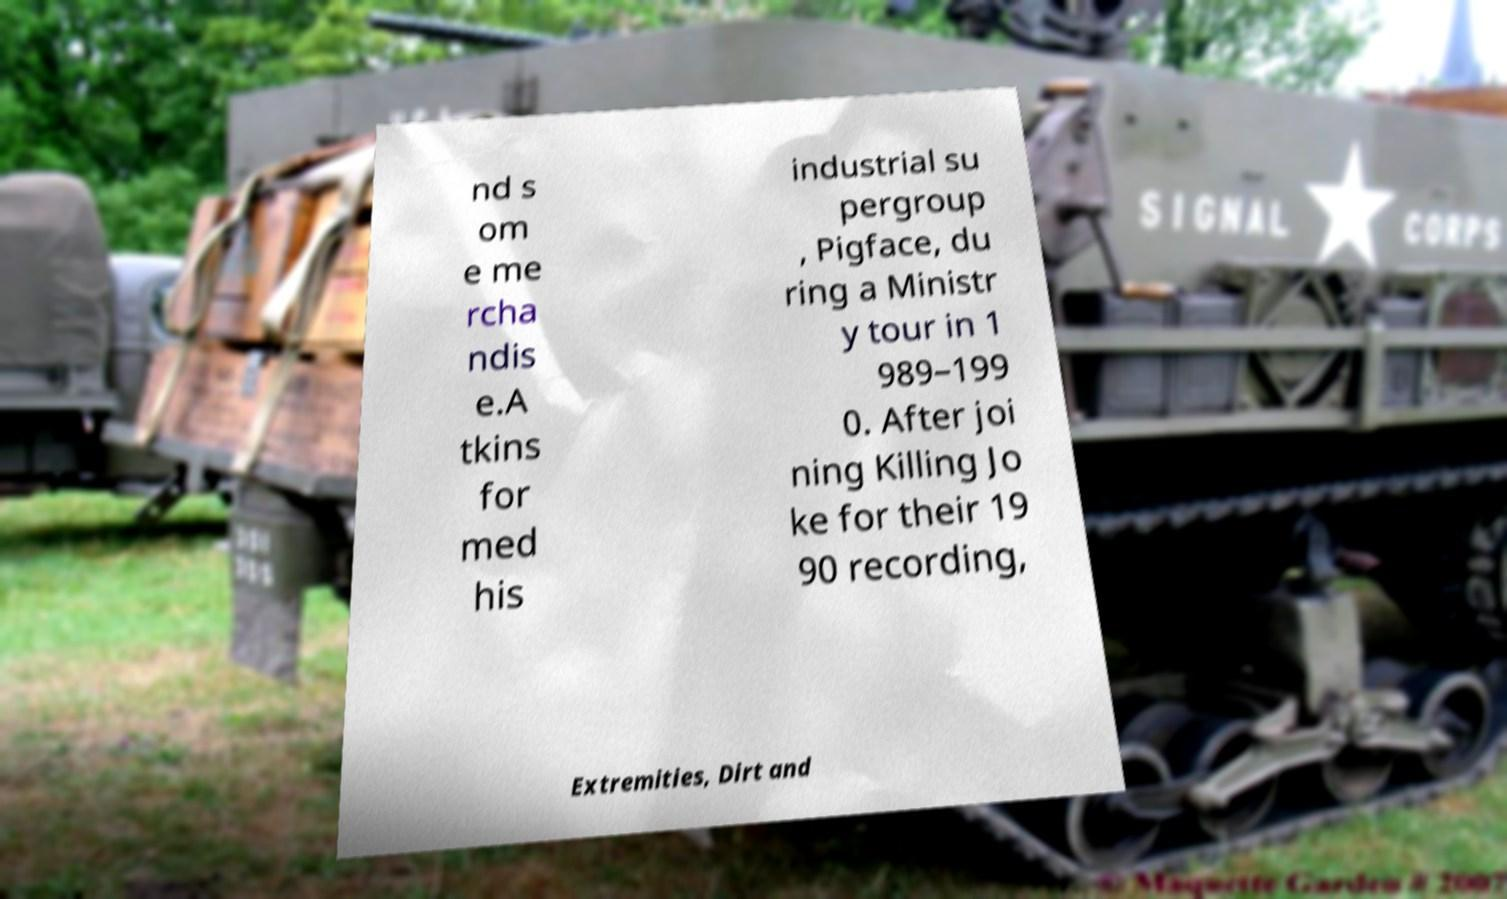Can you read and provide the text displayed in the image?This photo seems to have some interesting text. Can you extract and type it out for me? nd s om e me rcha ndis e.A tkins for med his industrial su pergroup , Pigface, du ring a Ministr y tour in 1 989–199 0. After joi ning Killing Jo ke for their 19 90 recording, Extremities, Dirt and 